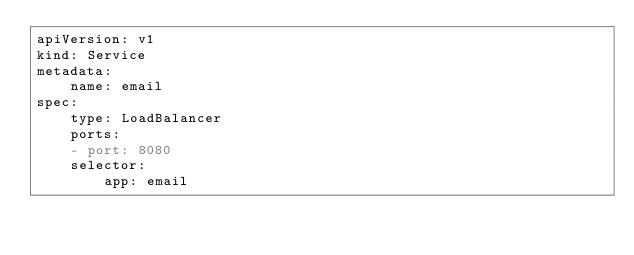<code> <loc_0><loc_0><loc_500><loc_500><_YAML_>apiVersion: v1
kind: Service
metadata:
    name: email
spec:
    type: LoadBalancer
    ports:
    - port: 8080
    selector:
        app: email</code> 